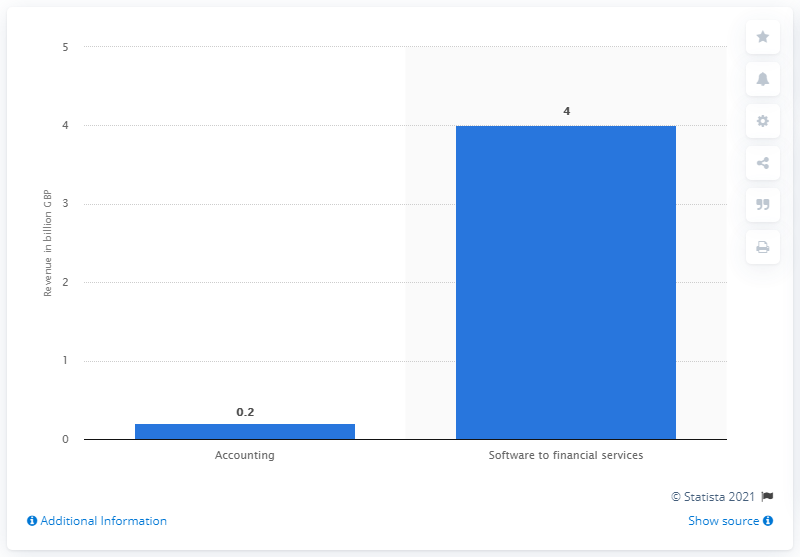Specify some key components in this picture. The financial software for financial services generated revenue of approximately $4 million in August 2014. 